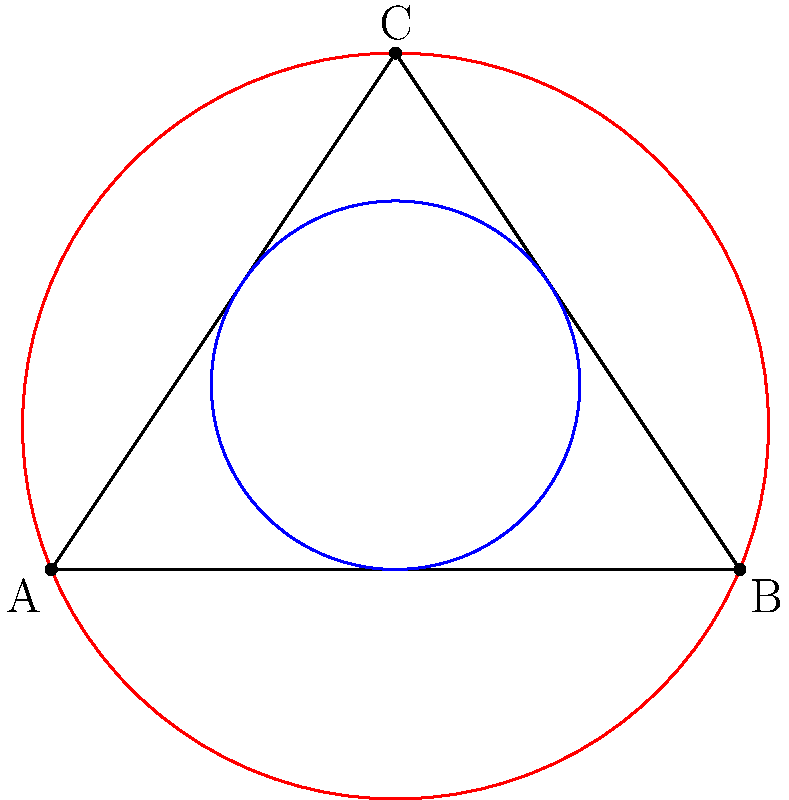In your latest novel, you've crafted a scene where a character discovers an ancient geometric theorem. The theorem relates to a triangle ABC with its inscribed circle (blue) of radius r and circumscribed circle (red) of radius R. If the area of the triangle is denoted by S and its semi-perimeter by s, prove that:

$$ \frac{1}{r} + \frac{1}{R} = \frac{2S}{s^2} $$

This equation is known as Euler's theorem. How does this relationship showcase the interconnectedness of geometric properties? Let's approach this proof step-by-step:

1) First, recall that for a triangle with sides a, b, and c:
   Area (S) = $\sqrt{s(s-a)(s-b)(s-c)}$ where $s = \frac{a+b+c}{2}$ (semi-perimeter)

2) The radius of the inscribed circle is given by: $r = \frac{S}{s}$

3) The radius of the circumscribed circle is given by: $R = \frac{abc}{4S}$

4) Now, let's start with the left side of Euler's equation:
   $\frac{1}{r} + \frac{1}{R}$

5) Substituting the expressions for r and R:
   $\frac{s}{S} + \frac{4S}{abc}$

6) Multiply both terms by S:
   $s + \frac{4S^2}{abc}$

7) Now, let's focus on the term $\frac{4S^2}{abc}$. We can rewrite this using the formula for S:
   $\frac{4s(s-a)(s-b)(s-c)}{abc}$

8) Expanding this:
   $\frac{4s^3 - 4s^2(a+b+c) + 4s(ab+bc+ca) - 4abc}{abc}$

9) Simplify, noting that $a+b+c = 2s$:
   $\frac{4s^3 - 8s^3 + 4s(ab+bc+ca) - 4abc}{abc} = \frac{4s(ab+bc+ca) - 4s^3 - 4abc}{abc}$

10) Factor out 4s:
    $\frac{4s(ab+bc+ca-s^2) - 4abc}{abc} = \frac{4s(ab+bc+ca-s^2)}{abc} - 4$

11) Substitute $s^2$ for $(ab+bc+ca)/2$:
    $\frac{4s(2s^2-s^2)}{abc} - 4 = \frac{4s^3}{abc} - 4 = s \cdot \frac{4S^2}{abc} - 4$

12) This simplifies to: $s \cdot \frac{1}{R} - 4$

13) Adding $\frac{1}{r}$ to both sides:
    $\frac{1}{r} + \frac{1}{R} = s \cdot \frac{1}{R} - 4 + \frac{1}{r} = \frac{s}{R} - 4 + \frac{s}{S}$

14) Simplify:
    $\frac{s}{R} + \frac{s}{S} - 4 = \frac{s^2}{RS} - 4 + 4 = \frac{2S}{s^2}$

Thus, we have proven Euler's theorem: $\frac{1}{r} + \frac{1}{R} = \frac{2S}{s^2}$

This relationship showcases the interconnectedness of geometric properties by linking the radii of the inscribed and circumscribed circles to the area and perimeter of the triangle, demonstrating a beautiful harmony in geometric relationships.
Answer: $\frac{1}{r} + \frac{1}{R} = \frac{2S}{s^2}$ 